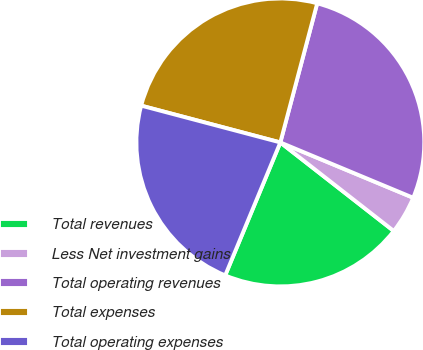Convert chart to OTSL. <chart><loc_0><loc_0><loc_500><loc_500><pie_chart><fcel>Total revenues<fcel>Less Net investment gains<fcel>Total operating revenues<fcel>Total expenses<fcel>Total operating expenses<nl><fcel>20.71%<fcel>4.27%<fcel>27.16%<fcel>25.01%<fcel>22.86%<nl></chart> 